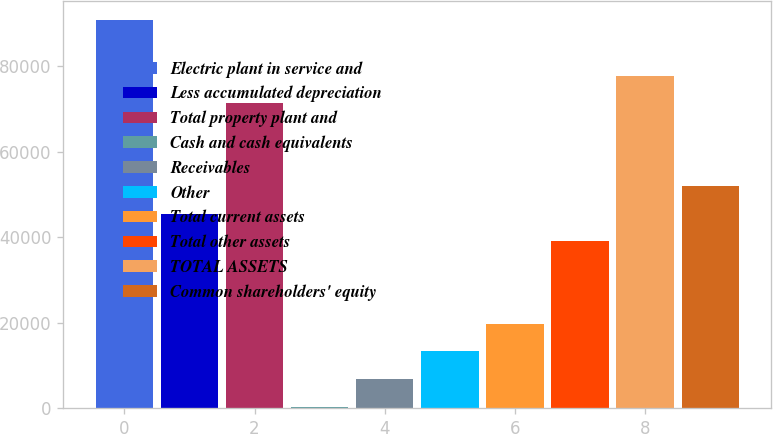Convert chart. <chart><loc_0><loc_0><loc_500><loc_500><bar_chart><fcel>Electric plant in service and<fcel>Less accumulated depreciation<fcel>Total property plant and<fcel>Cash and cash equivalents<fcel>Receivables<fcel>Other<fcel>Total current assets<fcel>Total other assets<fcel>TOTAL ASSETS<fcel>Common shareholders' equity<nl><fcel>90752.2<fcel>45540.6<fcel>71375.8<fcel>329<fcel>6787.8<fcel>13246.6<fcel>19705.4<fcel>39081.8<fcel>77834.6<fcel>51999.4<nl></chart> 